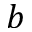Convert formula to latex. <formula><loc_0><loc_0><loc_500><loc_500>b</formula> 